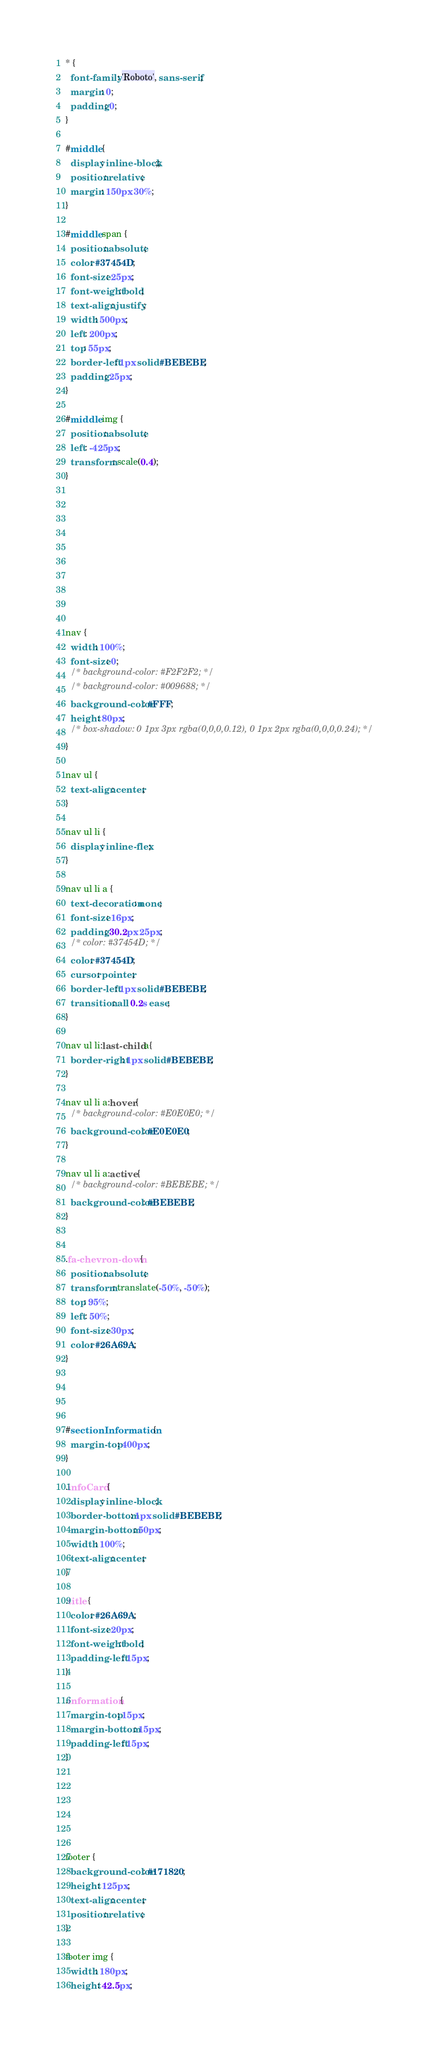<code> <loc_0><loc_0><loc_500><loc_500><_CSS_>* {
  font-family: 'Roboto', sans-serif;
  margin: 0;
  padding: 0;
}

#middle {
  display: inline-block;;
  position: relative;
  margin: 150px 30%;
}

#middle span {
  position: absolute;
  color: #37454D;
  font-size: 25px;
  font-weight: bold;
  text-align: justify;
  width: 500px;
  left: 200px;
  top: 55px;
  border-left: 1px solid #BEBEBE;
  padding: 25px;
}

#middle img {
  position: absolute;
  left: -425px;
  transform: scale(0.4);
}










nav {
  width: 100%;
  font-size: 0;
  /* background-color: #F2F2F2; */
  /* background-color: #009688; */
  background-color: #FFF;
  height: 80px;
  /* box-shadow: 0 1px 3px rgba(0,0,0,0.12), 0 1px 2px rgba(0,0,0,0.24); */
}

nav ul {
  text-align: center;
}

nav ul li {
  display: inline-flex;
}

nav ul li a {
  text-decoration: none;
  font-size: 16px;
  padding: 30.2px 25px;
  /* color: #37454D; */
  color: #37454D;
  cursor: pointer;
  border-left: 1px solid #BEBEBE;
  transition: all 0.2s ease;
}

nav ul li:last-child a{
  border-right: 1px solid #BEBEBE;
}

nav ul li a:hover {
  /* background-color: #E0E0E0; */
  background-color: #E0E0E0;
}

nav ul li a:active {
  /* background-color: #BEBEBE; */
  background-color: #BEBEBE;
}


.fa-chevron-down {
  position: absolute;
  transform: translate(-50%, -50%);
  top: 95%;
  left: 50%;
  font-size: 30px;
  color: #26A69A;
}




#sectionInformation {
  margin-top: 400px;
}

.infoCard {
  display: inline-block;
  border-bottom: 1px solid #BEBEBE;
  margin-bottom: 50px;
  width: 100%;
  text-align: center;
}

.title {
  color: #26A69A;
  font-size: 20px;
  font-weight: bold;
  padding-left: 15px;
}

.information {
  margin-top: 15px;
  margin-bottom: 15px;
  padding-left: 15px;
}






footer {
  background-color: #171820;
  height: 125px;
  text-align: center;
  position: relative;
}

footer img {
  width: 180px;
  height: 42.5px;</code> 